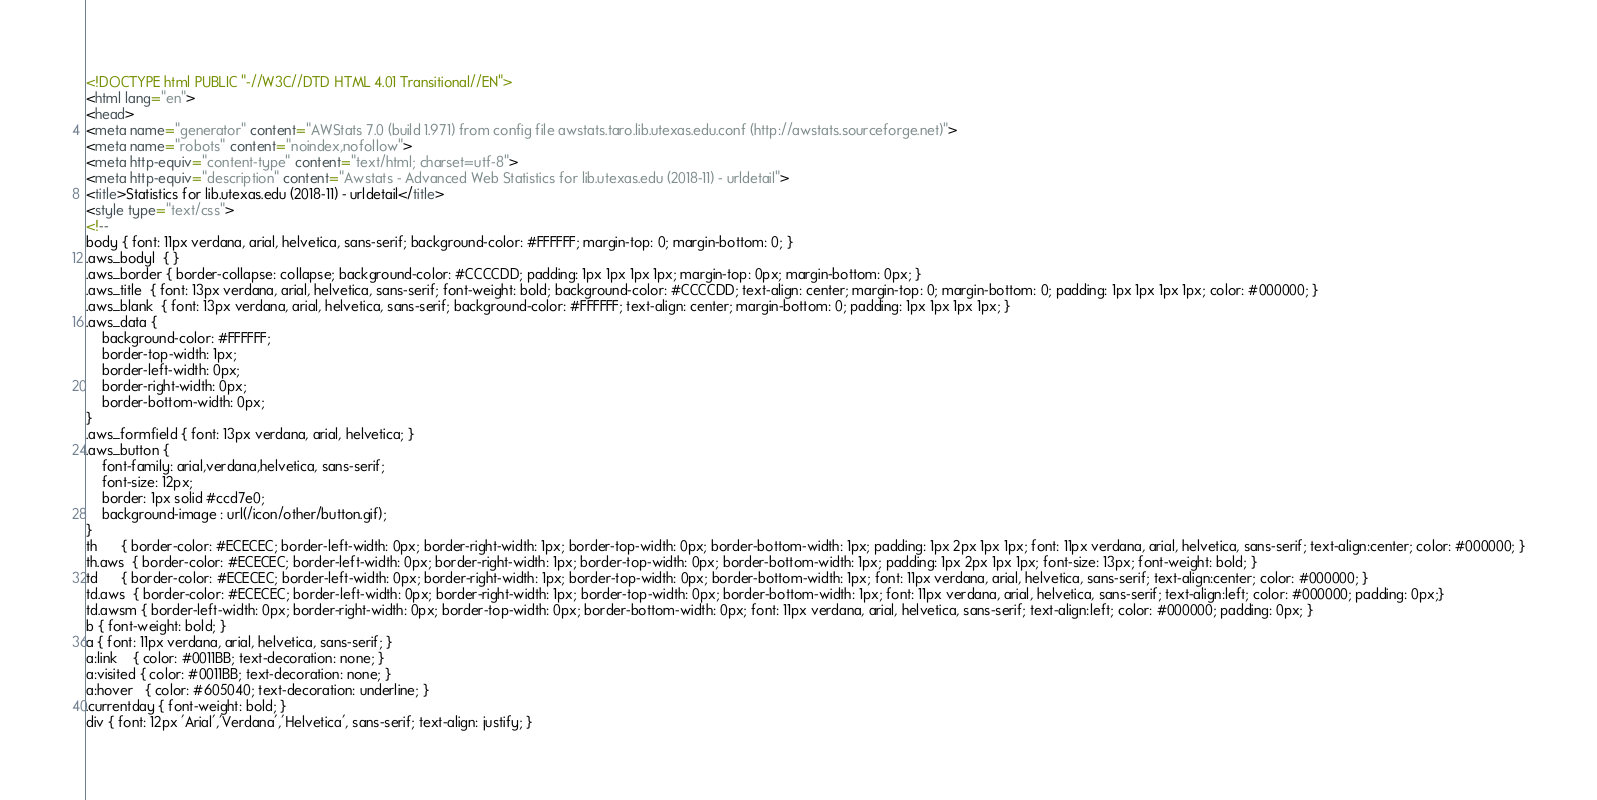<code> <loc_0><loc_0><loc_500><loc_500><_HTML_><!DOCTYPE html PUBLIC "-//W3C//DTD HTML 4.01 Transitional//EN">
<html lang="en">
<head>
<meta name="generator" content="AWStats 7.0 (build 1.971) from config file awstats.taro.lib.utexas.edu.conf (http://awstats.sourceforge.net)">
<meta name="robots" content="noindex,nofollow">
<meta http-equiv="content-type" content="text/html; charset=utf-8">
<meta http-equiv="description" content="Awstats - Advanced Web Statistics for lib.utexas.edu (2018-11) - urldetail">
<title>Statistics for lib.utexas.edu (2018-11) - urldetail</title>
<style type="text/css">
<!--
body { font: 11px verdana, arial, helvetica, sans-serif; background-color: #FFFFFF; margin-top: 0; margin-bottom: 0; }
.aws_bodyl  { }
.aws_border { border-collapse: collapse; background-color: #CCCCDD; padding: 1px 1px 1px 1px; margin-top: 0px; margin-bottom: 0px; }
.aws_title  { font: 13px verdana, arial, helvetica, sans-serif; font-weight: bold; background-color: #CCCCDD; text-align: center; margin-top: 0; margin-bottom: 0; padding: 1px 1px 1px 1px; color: #000000; }
.aws_blank  { font: 13px verdana, arial, helvetica, sans-serif; background-color: #FFFFFF; text-align: center; margin-bottom: 0; padding: 1px 1px 1px 1px; }
.aws_data {
	background-color: #FFFFFF;
	border-top-width: 1px;   
	border-left-width: 0px;  
	border-right-width: 0px; 
	border-bottom-width: 0px;
}
.aws_formfield { font: 13px verdana, arial, helvetica; }
.aws_button {
	font-family: arial,verdana,helvetica, sans-serif;
	font-size: 12px;
	border: 1px solid #ccd7e0;
	background-image : url(/icon/other/button.gif);
}
th		{ border-color: #ECECEC; border-left-width: 0px; border-right-width: 1px; border-top-width: 0px; border-bottom-width: 1px; padding: 1px 2px 1px 1px; font: 11px verdana, arial, helvetica, sans-serif; text-align:center; color: #000000; }
th.aws	{ border-color: #ECECEC; border-left-width: 0px; border-right-width: 1px; border-top-width: 0px; border-bottom-width: 1px; padding: 1px 2px 1px 1px; font-size: 13px; font-weight: bold; }
td		{ border-color: #ECECEC; border-left-width: 0px; border-right-width: 1px; border-top-width: 0px; border-bottom-width: 1px; font: 11px verdana, arial, helvetica, sans-serif; text-align:center; color: #000000; }
td.aws	{ border-color: #ECECEC; border-left-width: 0px; border-right-width: 1px; border-top-width: 0px; border-bottom-width: 1px; font: 11px verdana, arial, helvetica, sans-serif; text-align:left; color: #000000; padding: 0px;}
td.awsm	{ border-left-width: 0px; border-right-width: 0px; border-top-width: 0px; border-bottom-width: 0px; font: 11px verdana, arial, helvetica, sans-serif; text-align:left; color: #000000; padding: 0px; }
b { font-weight: bold; }
a { font: 11px verdana, arial, helvetica, sans-serif; }
a:link    { color: #0011BB; text-decoration: none; }
a:visited { color: #0011BB; text-decoration: none; }
a:hover   { color: #605040; text-decoration: underline; }
.currentday { font-weight: bold; }
div { font: 12px 'Arial','Verdana','Helvetica', sans-serif; text-align: justify; }</code> 